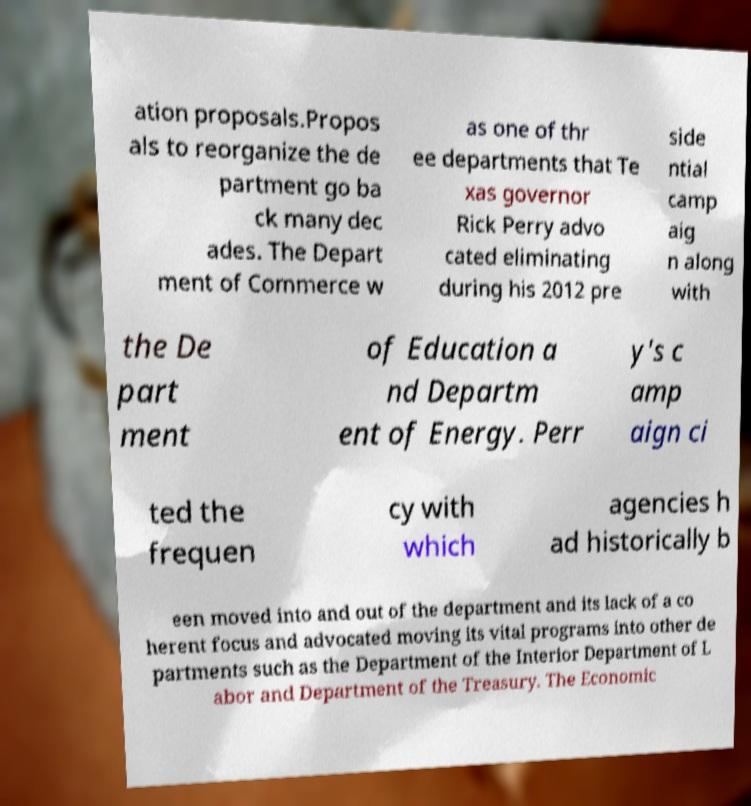Please identify and transcribe the text found in this image. ation proposals.Propos als to reorganize the de partment go ba ck many dec ades. The Depart ment of Commerce w as one of thr ee departments that Te xas governor Rick Perry advo cated eliminating during his 2012 pre side ntial camp aig n along with the De part ment of Education a nd Departm ent of Energy. Perr y's c amp aign ci ted the frequen cy with which agencies h ad historically b een moved into and out of the department and its lack of a co herent focus and advocated moving its vital programs into other de partments such as the Department of the Interior Department of L abor and Department of the Treasury. The Economic 